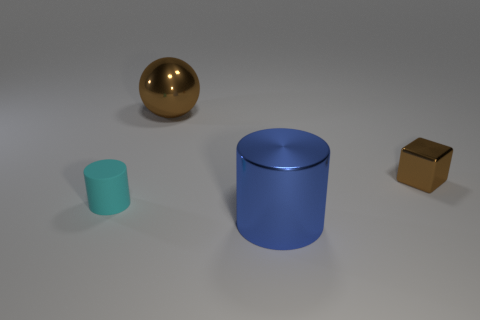Subtract all blue cylinders. How many cylinders are left? 1 Subtract all spheres. How many objects are left? 3 Add 3 blue metal cylinders. How many objects exist? 7 Subtract all brown cylinders. Subtract all blue blocks. How many cylinders are left? 2 Subtract all brown balls. How many blue cylinders are left? 1 Subtract all tiny cubes. Subtract all tiny matte cylinders. How many objects are left? 2 Add 2 small brown metal things. How many small brown metal things are left? 3 Add 1 shiny blocks. How many shiny blocks exist? 2 Subtract 0 gray spheres. How many objects are left? 4 Subtract 1 cylinders. How many cylinders are left? 1 